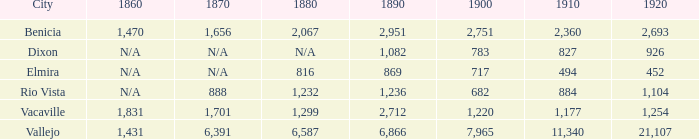What is the 1920 figure when 1890 exceeds 1,236, 1910 is below 1,177, and the city is vacaville? None. 